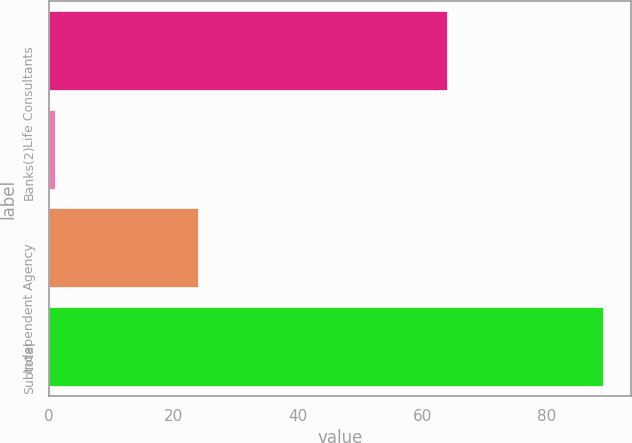<chart> <loc_0><loc_0><loc_500><loc_500><bar_chart><fcel>Life Consultants<fcel>Banks(2)<fcel>Independent Agency<fcel>Subtotal<nl><fcel>64<fcel>1<fcel>24<fcel>89<nl></chart> 